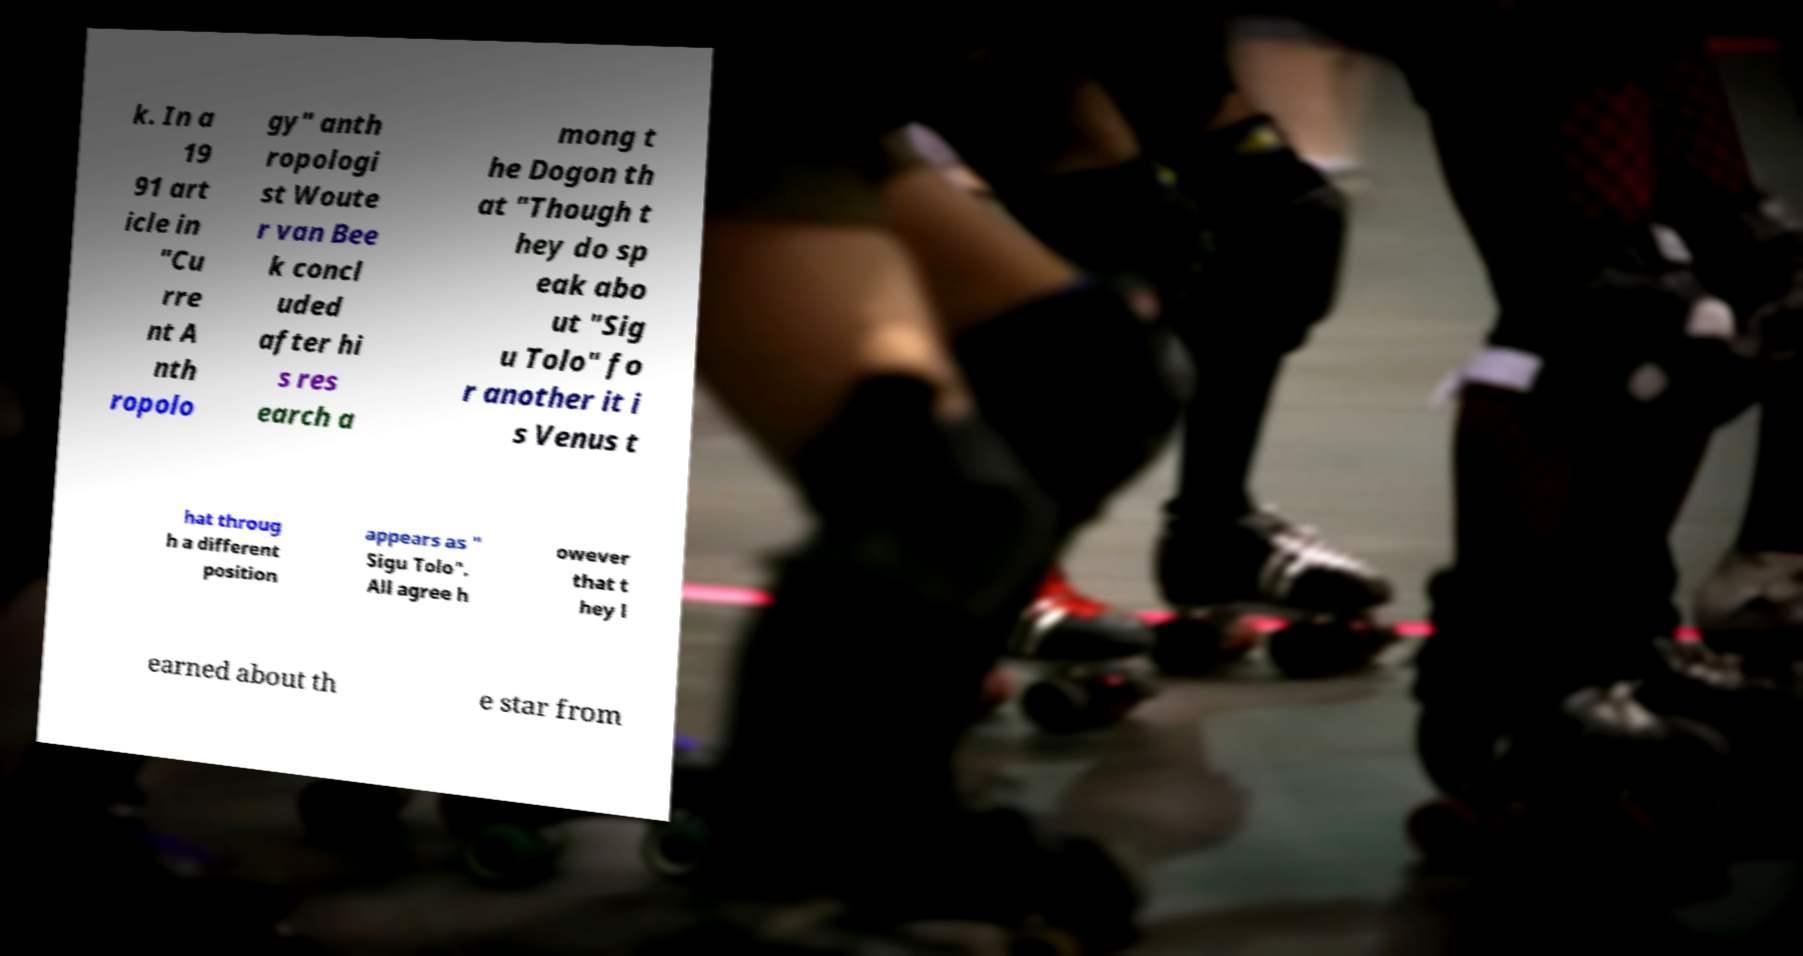Could you assist in decoding the text presented in this image and type it out clearly? k. In a 19 91 art icle in "Cu rre nt A nth ropolo gy" anth ropologi st Woute r van Bee k concl uded after hi s res earch a mong t he Dogon th at "Though t hey do sp eak abo ut "Sig u Tolo" fo r another it i s Venus t hat throug h a different position appears as " Sigu Tolo". All agree h owever that t hey l earned about th e star from 